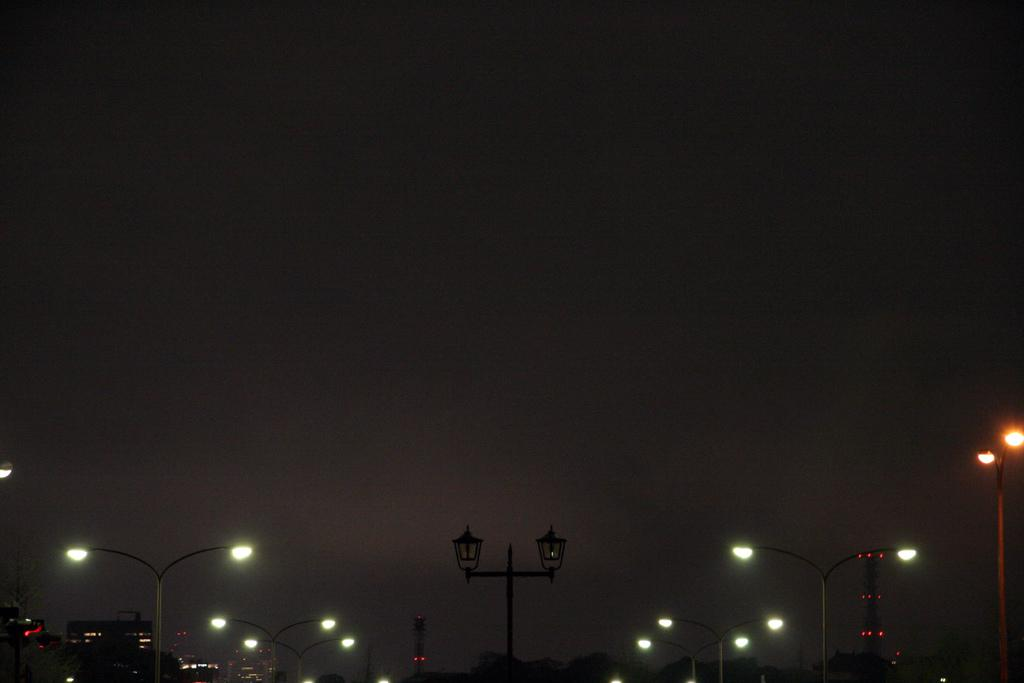What structures are present in the image? There are poles and lights in the image. What can be seen on the left side of the image? There is a building on the left side of the image. What tall structure is visible in the image? There is a tower in the image. What is visible at the top of the image? The sky is visible at the top of the image. What type of surprise can be seen in the image? There is no surprise present in the image; it features poles, lights, a building, and a tower. What type of wool is used to make the button in the image? There is no button or wool present in the image. 